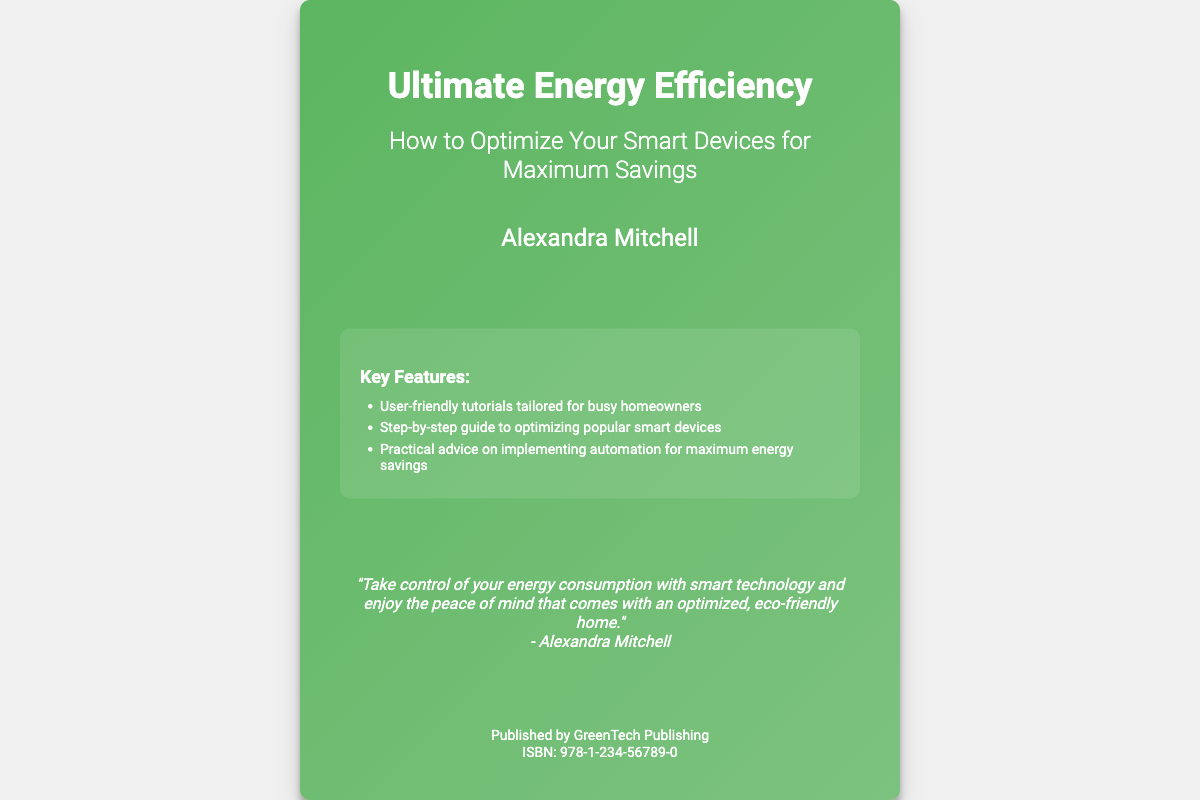What is the book title? The title is prominently displayed at the top of the book cover, indicating the main subject of the book.
Answer: Ultimate Energy Efficiency Who is the author of the book? The author's name is mentioned below the subtitle, indicating the person who wrote the book.
Answer: Alexandra Mitchell What is the book's subtitle? The subtitle is located right under the title, providing further context about the book's content.
Answer: How to Optimize Your Smart Devices for Maximum Savings What type of publishing company released this book? The publisher is mentioned at the bottom of the cover, providing information about the company that published the book.
Answer: GreenTech Publishing What feature is highlighted for busy homeowners? The highlights section includes specific features meant for the targeted audience, focusing on user-friendly aspects.
Answer: User-friendly tutorials tailored for busy homeowners How many key features are listed in the highlights? The bullet points in the highlights section provide the count of features mentioned.
Answer: Three What quote is attributed to the author on the cover? The quote is provided in a distinct section of the cover, reflecting the author's viewpoint on energy consumption.
Answer: "Take control of your energy consumption with smart technology and enjoy the peace of mind that comes with an optimized, eco-friendly home." What is the ISBN number of the book? The ISBN is given in the publisher's section, which identifies the book uniquely.
Answer: 978-1-234-56789-0 